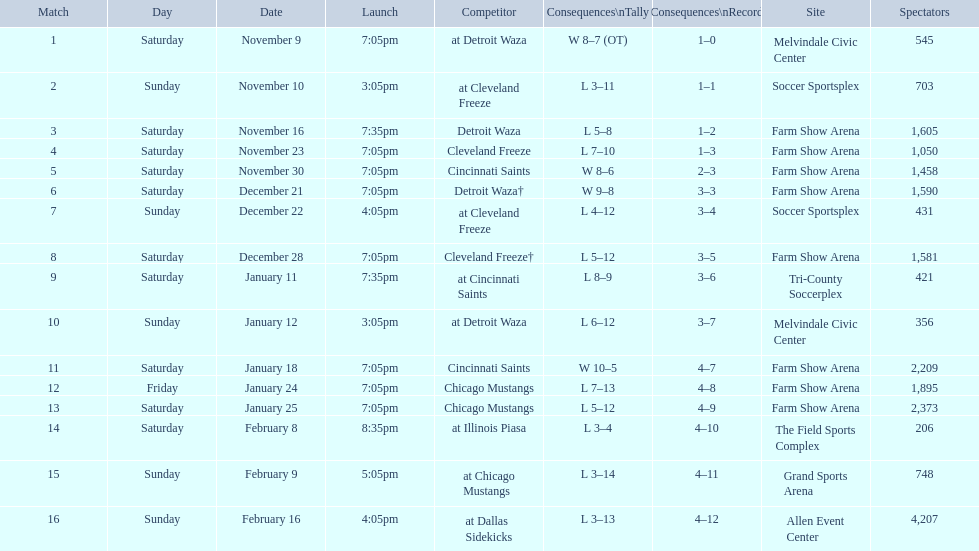How many games did the harrisburg heat lose to the cleveland freeze in total. 4. 